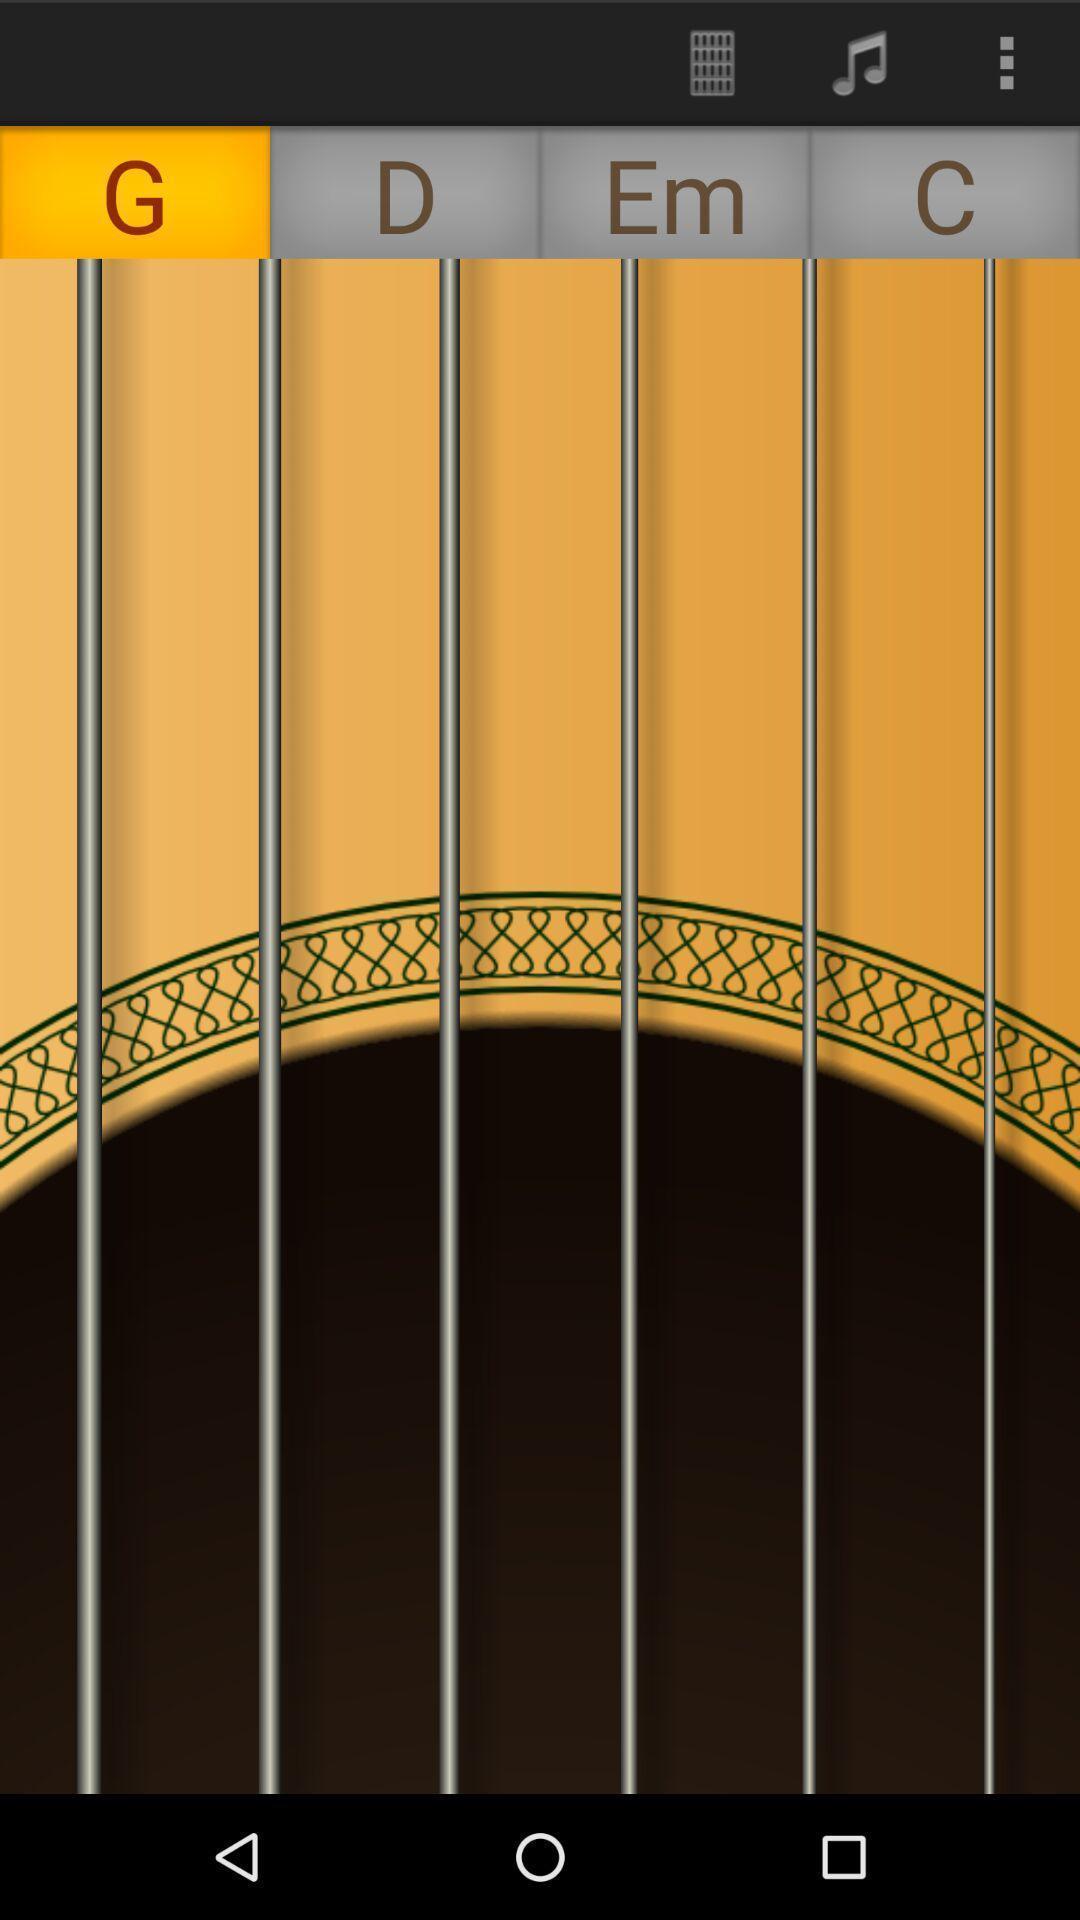Describe the key features of this screenshot. Screen shows a guitar app. 